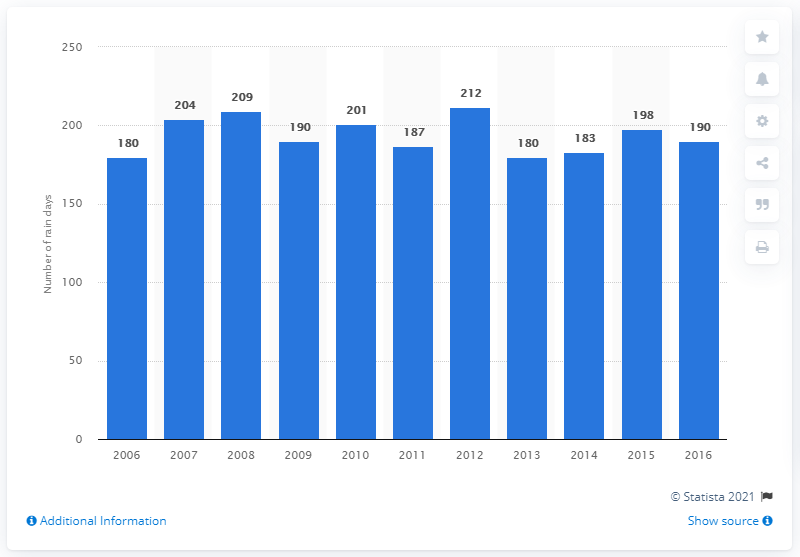Highlight a few significant elements in this photo. In 2016, it rained a total of 190 days in Belgium. 